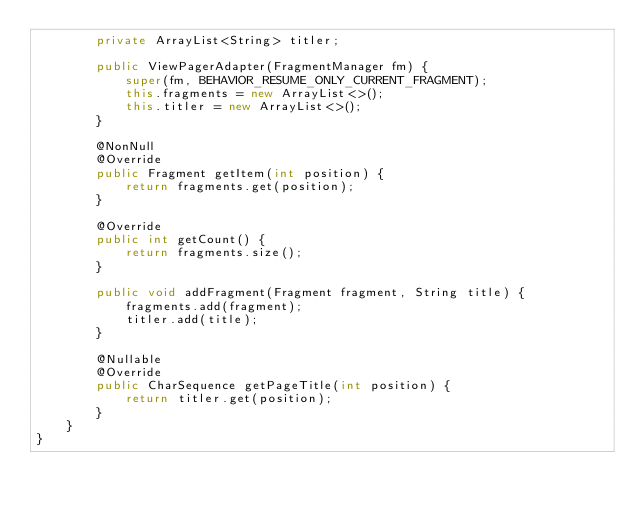Convert code to text. <code><loc_0><loc_0><loc_500><loc_500><_Java_>        private ArrayList<String> titler;

        public ViewPagerAdapter(FragmentManager fm) {
            super(fm, BEHAVIOR_RESUME_ONLY_CURRENT_FRAGMENT);
            this.fragments = new ArrayList<>();
            this.titler = new ArrayList<>();
        }

        @NonNull
        @Override
        public Fragment getItem(int position) {
            return fragments.get(position);
        }

        @Override
        public int getCount() {
            return fragments.size();
        }

        public void addFragment(Fragment fragment, String title) {
            fragments.add(fragment);
            titler.add(title);
        }

        @Nullable
        @Override
        public CharSequence getPageTitle(int position) {
            return titler.get(position);
        }
    }
}
</code> 